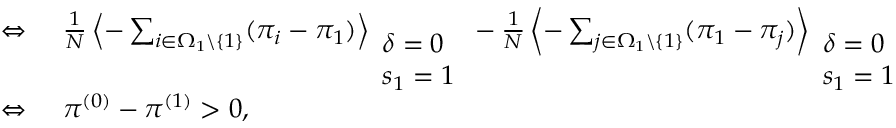<formula> <loc_0><loc_0><loc_500><loc_500>\begin{array} { r l } { \Leftrightarrow } & \frac { 1 } { N } \left \langle - \sum _ { i \in \Omega _ { 1 } \ \{ 1 \} } ( \pi _ { i } - \pi _ { 1 } ) \right \rangle _ { \begin{array} { l } { \delta = 0 } \\ { s _ { 1 } = 1 } \end{array} } - \frac { 1 } { N } \left \langle - \sum _ { j \in \Omega _ { 1 } \ \{ 1 \} } ( \pi _ { 1 } - \pi _ { j } ) \right \rangle _ { \begin{array} { l } { \delta = 0 } \\ { s _ { 1 } = 1 } \end{array} } > 0 } \\ { \Leftrightarrow } & \pi ^ { ( 0 ) } - \pi ^ { ( 1 ) } > 0 , } \end{array}</formula> 